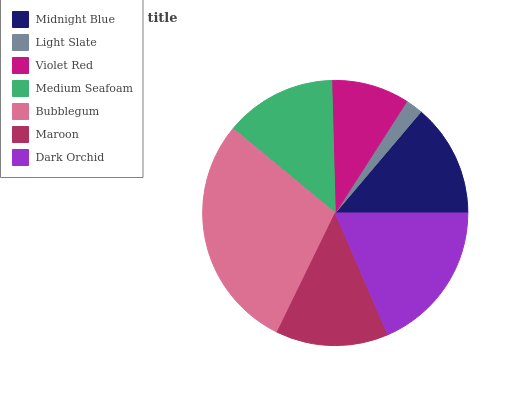Is Light Slate the minimum?
Answer yes or no. Yes. Is Bubblegum the maximum?
Answer yes or no. Yes. Is Violet Red the minimum?
Answer yes or no. No. Is Violet Red the maximum?
Answer yes or no. No. Is Violet Red greater than Light Slate?
Answer yes or no. Yes. Is Light Slate less than Violet Red?
Answer yes or no. Yes. Is Light Slate greater than Violet Red?
Answer yes or no. No. Is Violet Red less than Light Slate?
Answer yes or no. No. Is Maroon the high median?
Answer yes or no. Yes. Is Maroon the low median?
Answer yes or no. Yes. Is Violet Red the high median?
Answer yes or no. No. Is Dark Orchid the low median?
Answer yes or no. No. 